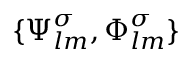<formula> <loc_0><loc_0><loc_500><loc_500>\{ \Psi _ { l m } ^ { \sigma } , \Phi _ { l m } ^ { \sigma } \}</formula> 